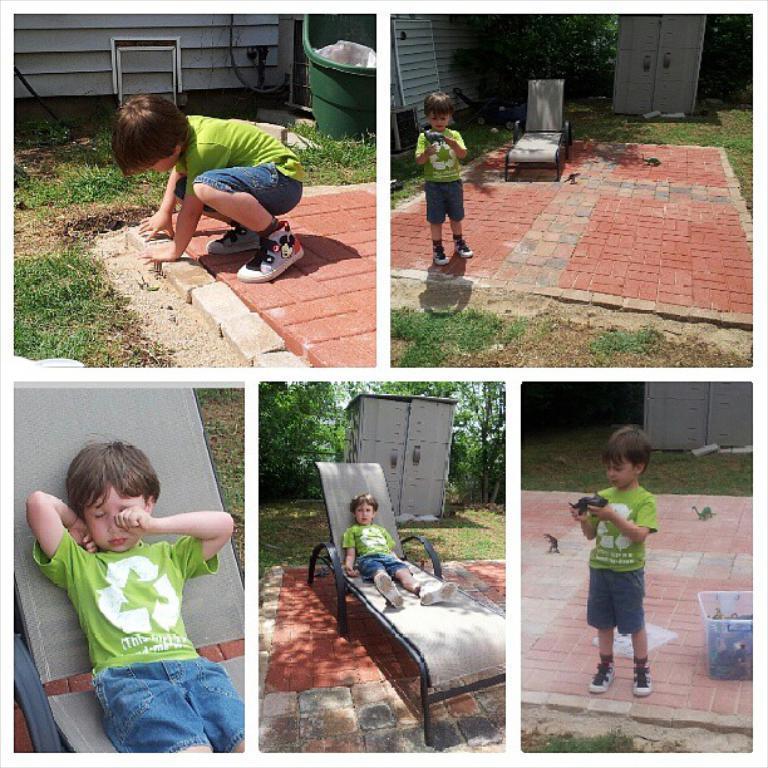Can you describe this image briefly? This is a collage picture,in this picture we can see a boy,he is standing,sitting on a bench and in the background we can see trees. 